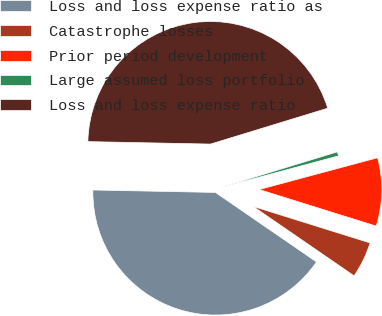Convert chart to OTSL. <chart><loc_0><loc_0><loc_500><loc_500><pie_chart><fcel>Loss and loss expense ratio as<fcel>Catastrophe losses<fcel>Prior period development<fcel>Large assumed loss portfolio<fcel>Loss and loss expense ratio<nl><fcel>40.73%<fcel>4.77%<fcel>8.99%<fcel>0.55%<fcel>44.95%<nl></chart> 